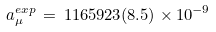Convert formula to latex. <formula><loc_0><loc_0><loc_500><loc_500>a _ { \mu } ^ { e x p } \, = \, 1 1 6 5 9 2 3 ( 8 . 5 ) \times 1 0 ^ { - 9 }</formula> 